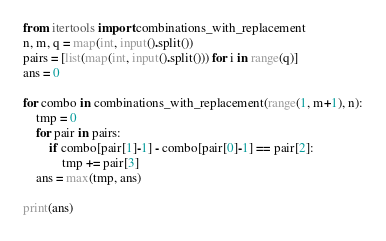<code> <loc_0><loc_0><loc_500><loc_500><_Python_>from itertools import combinations_with_replacement
n, m, q = map(int, input().split())
pairs = [list(map(int, input().split())) for i in range(q)]
ans = 0

for combo in combinations_with_replacement(range(1, m+1), n):
    tmp = 0
    for pair in pairs:
        if combo[pair[1]-1] - combo[pair[0]-1] == pair[2]:
            tmp += pair[3]
    ans = max(tmp, ans)

print(ans)
</code> 